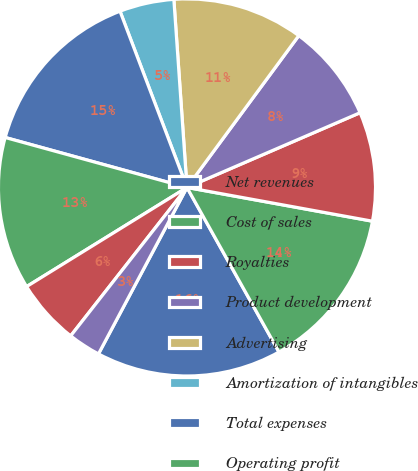Convert chart to OTSL. <chart><loc_0><loc_0><loc_500><loc_500><pie_chart><fcel>Net revenues<fcel>Cost of sales<fcel>Royalties<fcel>Product development<fcel>Advertising<fcel>Amortization of intangibles<fcel>Total expenses<fcel>Operating profit<fcel>Interest expense<fcel>Interest income<nl><fcel>15.89%<fcel>14.02%<fcel>9.35%<fcel>8.41%<fcel>11.21%<fcel>4.67%<fcel>14.95%<fcel>13.08%<fcel>5.61%<fcel>2.8%<nl></chart> 